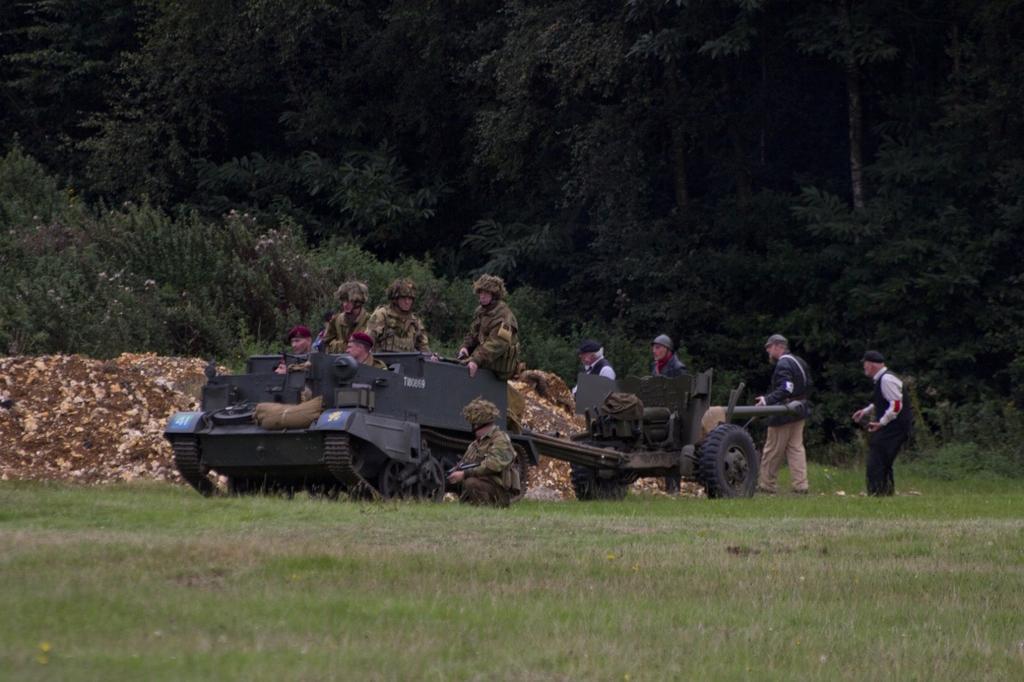Describe this image in one or two sentences. In this image I can see few people are sitting on the military tank. In the background I can see four people are walking. On the top of the image I can see the trees. On the bottom of the image there is a grass. 